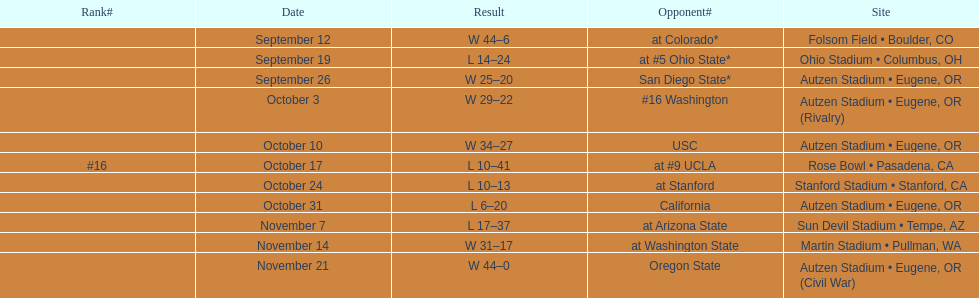Write the full table. {'header': ['Rank#', 'Date', 'Result', 'Opponent#', 'Site'], 'rows': [['', 'September 12', 'W\xa044–6', 'at\xa0Colorado*', 'Folsom Field • Boulder, CO'], ['', 'September 19', 'L\xa014–24', 'at\xa0#5\xa0Ohio State*', 'Ohio Stadium • Columbus, OH'], ['', 'September 26', 'W\xa025–20', 'San Diego State*', 'Autzen Stadium • Eugene, OR'], ['', 'October 3', 'W\xa029–22', '#16\xa0Washington', 'Autzen Stadium • Eugene, OR (Rivalry)'], ['', 'October 10', 'W\xa034–27', 'USC', 'Autzen Stadium • Eugene, OR'], ['#16', 'October 17', 'L\xa010–41', 'at\xa0#9\xa0UCLA', 'Rose Bowl • Pasadena, CA'], ['', 'October 24', 'L\xa010–13', 'at\xa0Stanford', 'Stanford Stadium • Stanford, CA'], ['', 'October 31', 'L\xa06–20', 'California', 'Autzen Stadium • Eugene, OR'], ['', 'November 7', 'L\xa017–37', 'at\xa0Arizona State', 'Sun Devil Stadium • Tempe, AZ'], ['', 'November 14', 'W\xa031–17', 'at\xa0Washington State', 'Martin Stadium • Pullman, WA'], ['', 'November 21', 'W\xa044–0', 'Oregon State', 'Autzen Stadium • Eugene, OR (Civil War)']]} Between september 26 and october 24, how many games were played in eugene, or? 3. 